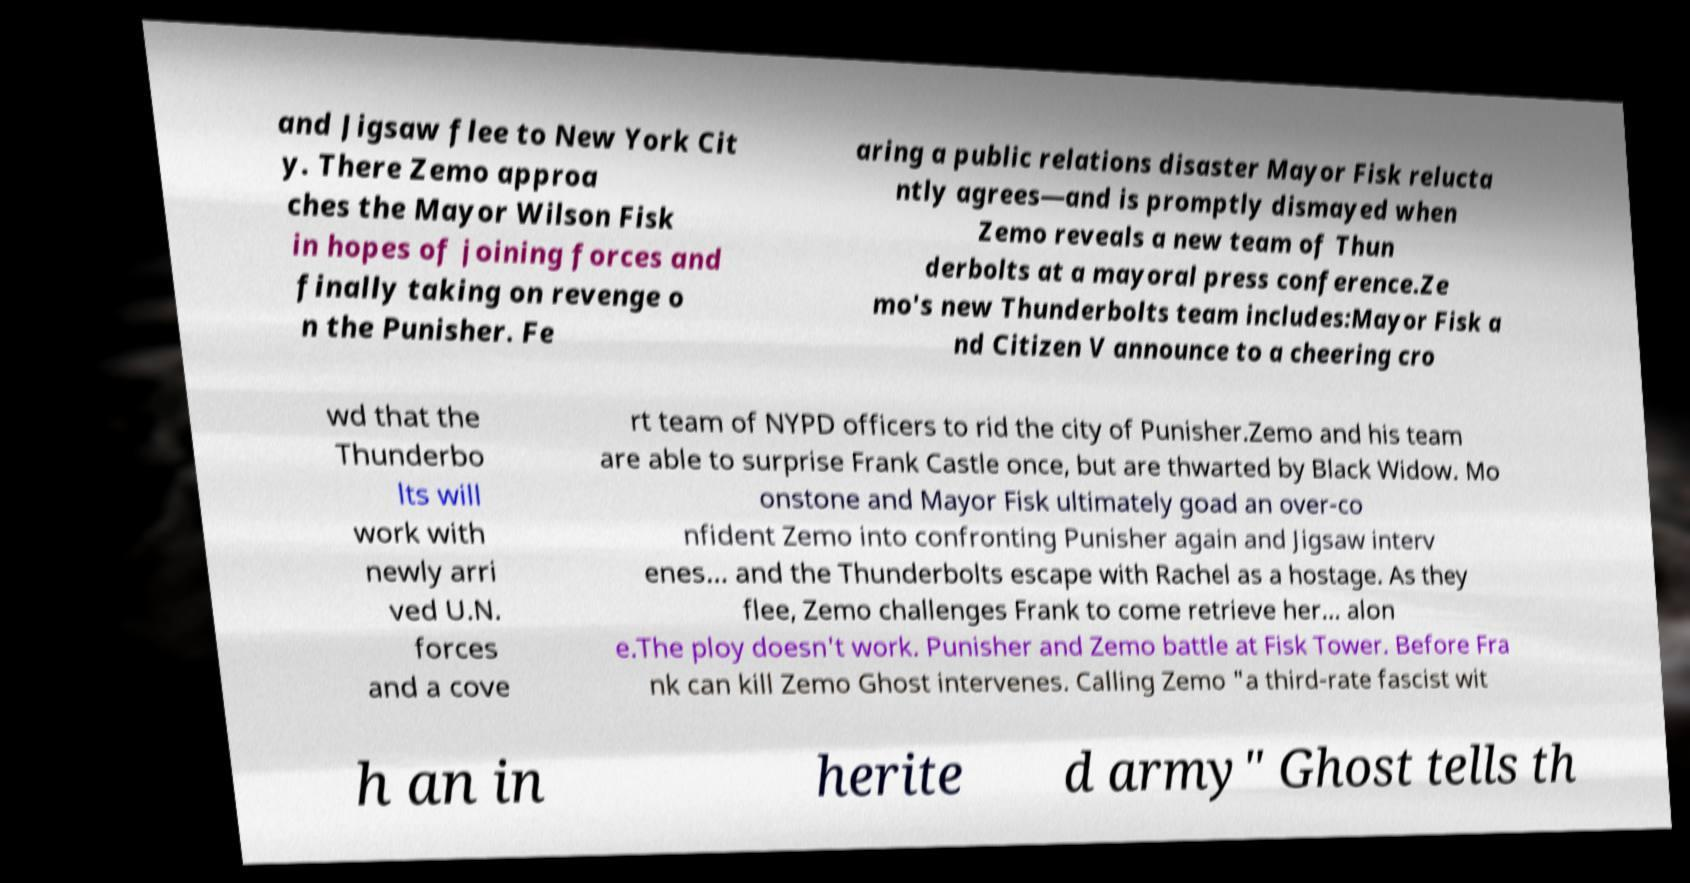Can you read and provide the text displayed in the image?This photo seems to have some interesting text. Can you extract and type it out for me? and Jigsaw flee to New York Cit y. There Zemo approa ches the Mayor Wilson Fisk in hopes of joining forces and finally taking on revenge o n the Punisher. Fe aring a public relations disaster Mayor Fisk relucta ntly agrees—and is promptly dismayed when Zemo reveals a new team of Thun derbolts at a mayoral press conference.Ze mo's new Thunderbolts team includes:Mayor Fisk a nd Citizen V announce to a cheering cro wd that the Thunderbo lts will work with newly arri ved U.N. forces and a cove rt team of NYPD officers to rid the city of Punisher.Zemo and his team are able to surprise Frank Castle once, but are thwarted by Black Widow. Mo onstone and Mayor Fisk ultimately goad an over-co nfident Zemo into confronting Punisher again and Jigsaw interv enes... and the Thunderbolts escape with Rachel as a hostage. As they flee, Zemo challenges Frank to come retrieve her... alon e.The ploy doesn't work. Punisher and Zemo battle at Fisk Tower. Before Fra nk can kill Zemo Ghost intervenes. Calling Zemo "a third-rate fascist wit h an in herite d army" Ghost tells th 